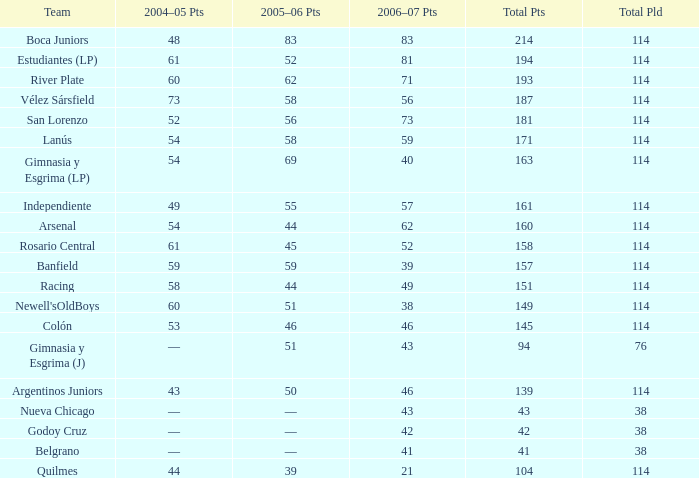What is the total number of points for a total pld less than 38? 0.0. 